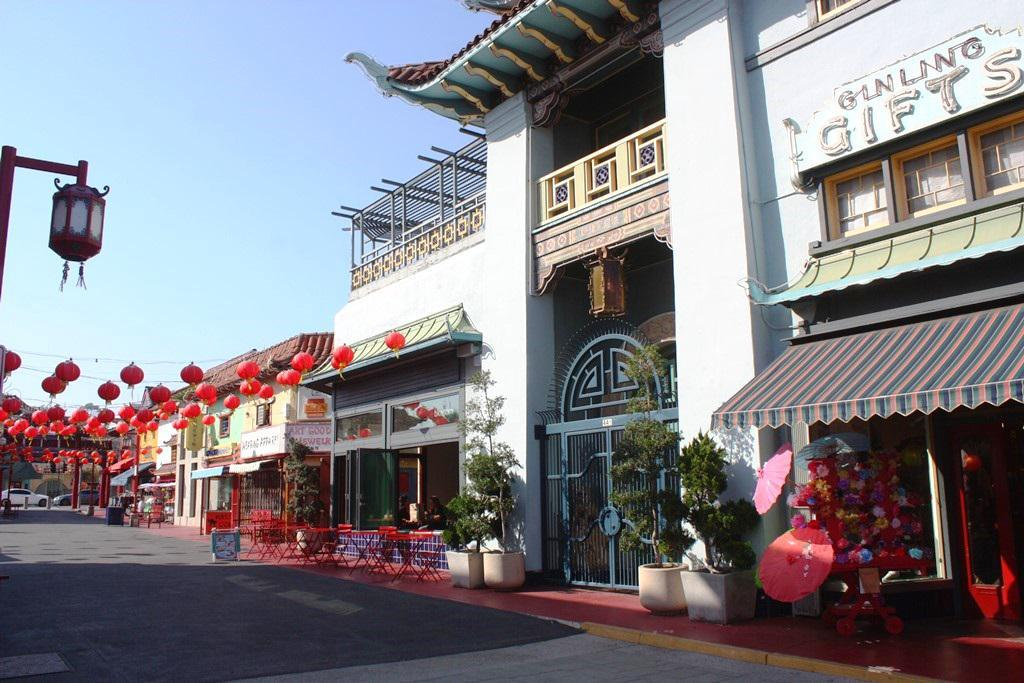What types of objects can be seen in the image? There are plants, buildings, cars, umbrellas, decorative balls, chairs, tables, boards, a gate, and poles in the image. What is the primary setting of the image? The image appears to be set in an outdoor area with a mix of natural and urban elements. What can be seen in the background of the image? The sky is visible in the background of the image. How many types of vehicles are present in the image? There is only one type of vehicle mentioned, which are cars. What type of alarm can be heard going off in the image? There is no alarm present in the image, and therefore no sound can be heard. Can you see any boats in the image? There are no boats mentioned or visible in the image. 